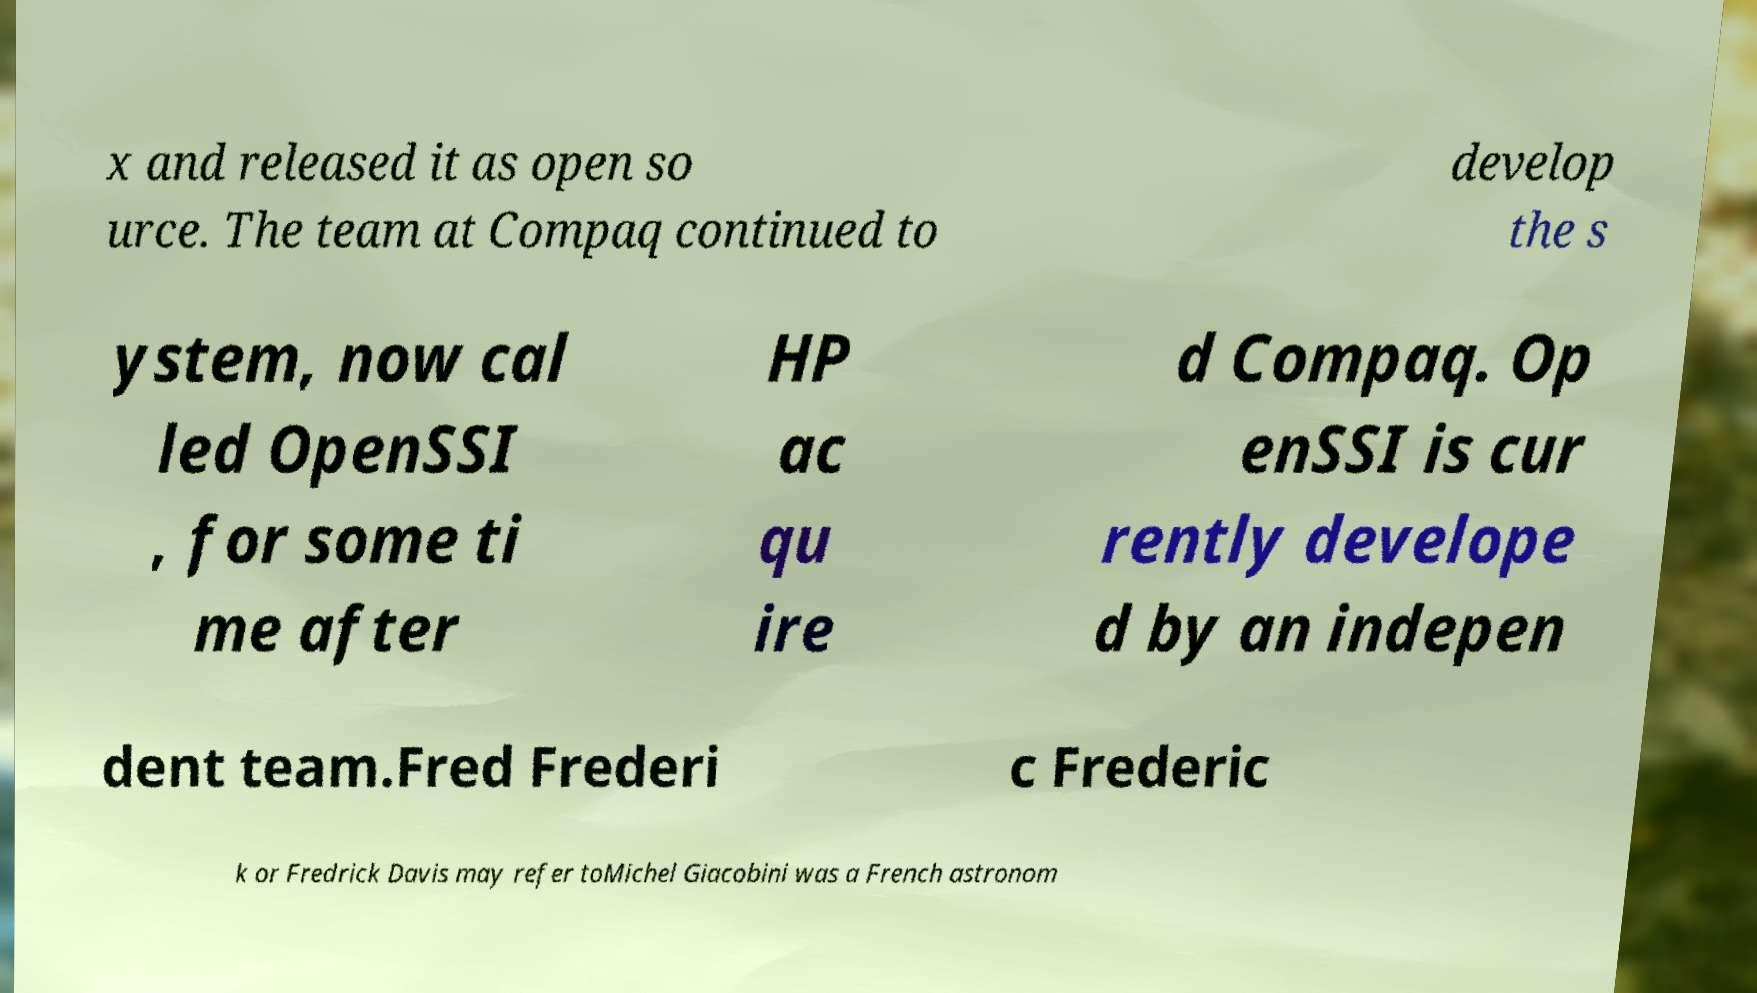What messages or text are displayed in this image? I need them in a readable, typed format. x and released it as open so urce. The team at Compaq continued to develop the s ystem, now cal led OpenSSI , for some ti me after HP ac qu ire d Compaq. Op enSSI is cur rently develope d by an indepen dent team.Fred Frederi c Frederic k or Fredrick Davis may refer toMichel Giacobini was a French astronom 